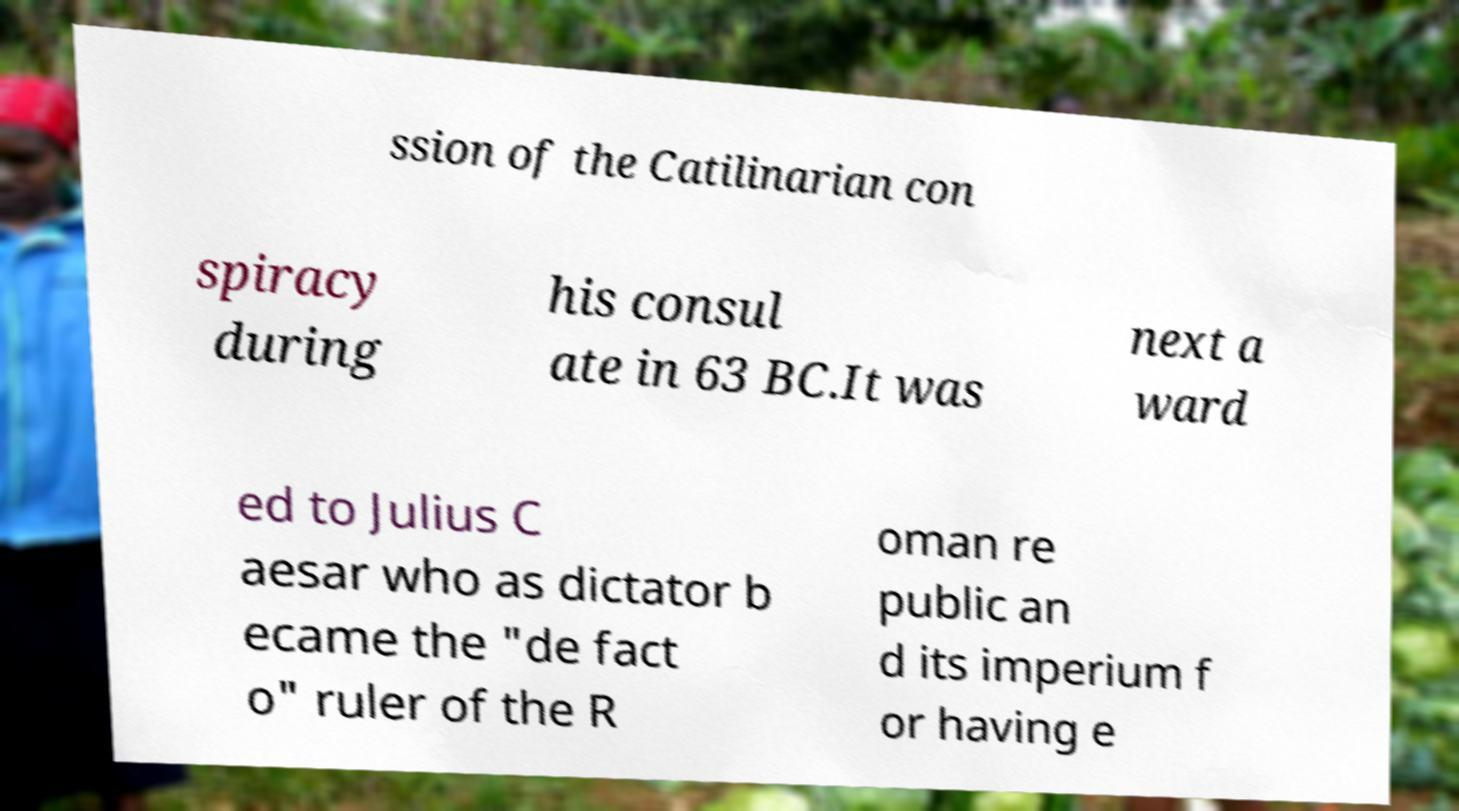For documentation purposes, I need the text within this image transcribed. Could you provide that? ssion of the Catilinarian con spiracy during his consul ate in 63 BC.It was next a ward ed to Julius C aesar who as dictator b ecame the "de fact o" ruler of the R oman re public an d its imperium f or having e 